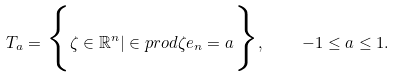<formula> <loc_0><loc_0><loc_500><loc_500>T _ { a } = \Big { \{ } \zeta \in \mathbb { R } ^ { n } | \in p r o d { \zeta } { e _ { n } } = a \Big { \} } , \quad - 1 \leq a \leq 1 .</formula> 